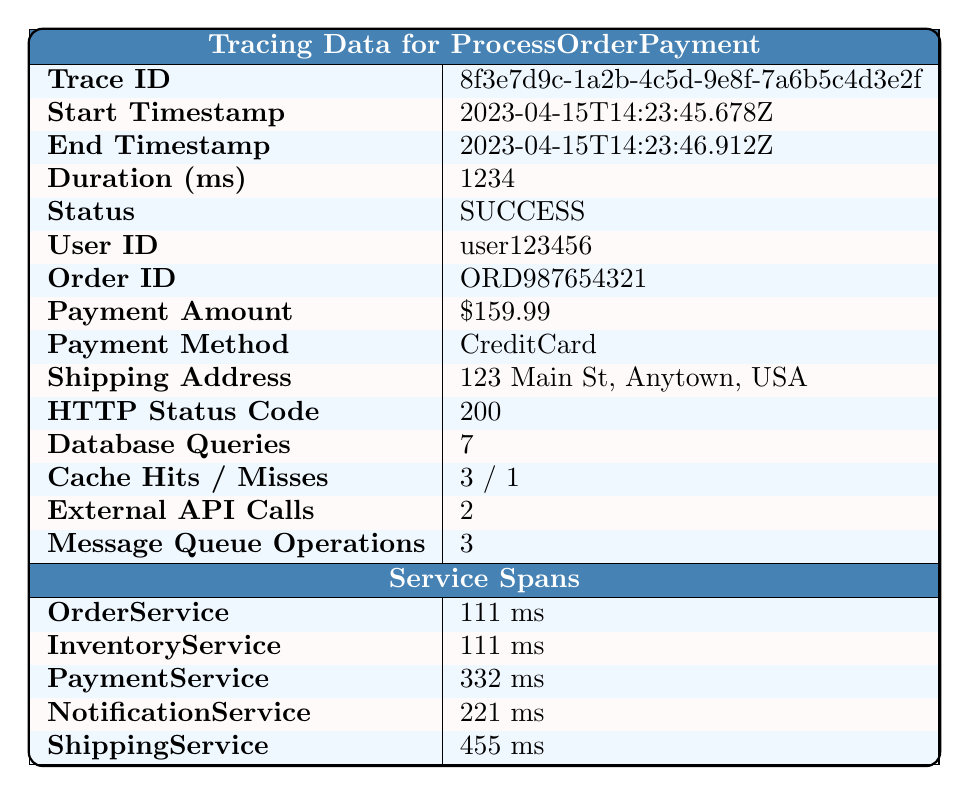What is the trace ID for the transaction? The trace ID is explicitly listed in the table under "Trace ID."
Answer: 8f3e7d9c-1a2b-4c5d-9e8f-7a6b5c4d3e2f What was the total duration of the transaction in milliseconds? The total duration is stated in the table under "Duration (ms)."
Answer: 1234 Which service had the longest duration? The table lists the durations for each service, and "ShippingService" at 455 ms is the longest.
Answer: ShippingService Did the transaction complete successfully? The "Status" field indicates whether the transaction was successful or not. It states "SUCCESS."
Answer: Yes What was the payment amount for the order? The payment amount is found in the table under "Payment Amount."
Answer: $159.99 How many services were involved in processing the order? The table lists five services under "Service Spans."
Answer: 5 What is the average duration of the services involved? The durations for the services are 111 ms, 111 ms, 332 ms, 221 ms, and 455 ms. The sum is 111 + 111 + 332 + 221 + 455 = 1230 ms. There are 5 services, so the average is 1230 / 5 = 246 ms.
Answer: 246 ms Is there any error recorded for this transaction? The table includes a field for "Errors," which is empty, indicating no errors were recorded.
Answer: No What is the ratio of cache hits to cache misses? The cache hits are 3 and cache misses are 1, so the ratio is calculated as 3:1.
Answer: 3:1 Which service was responsible for the highest processing time, and how much time did it take? The service durations show "ShippingService" taking 455 ms, which is the highest.
Answer: ShippingService, 455 ms What was the HTTP status code for the transaction? The HTTP status code is directly listed in the table.
Answer: 200 If the PaymentService was responsible for 332 ms, how much time was taken by the other services combined? Summing the other service durations: 111 ms (OrderService) + 111 ms (InventoryService) + 221 ms (NotificationService) = 443 ms. So, the combined time is 443 ms.
Answer: 443 ms What is the total number of database queries made during this transaction? The number of database queries is mentioned in the "Database Queries" section of the table.
Answer: 7 Which service started processing last based on the start times? By comparing start times: OrderService at 14:23:45.678, InventoryService at 14:23:45.790, PaymentService at 14:23:45.902, NotificationService at 14:23:46.235, and ShippingService at 14:23:46.457, ShippingService had the last start time.
Answer: ShippingService What was the duration difference between the longest and shortest service? The longest service is ShippingService (455 ms) and the shortest is either OrderService or InventoryService (both 111 ms). The difference is 455 - 111 = 344 ms.
Answer: 344 ms 